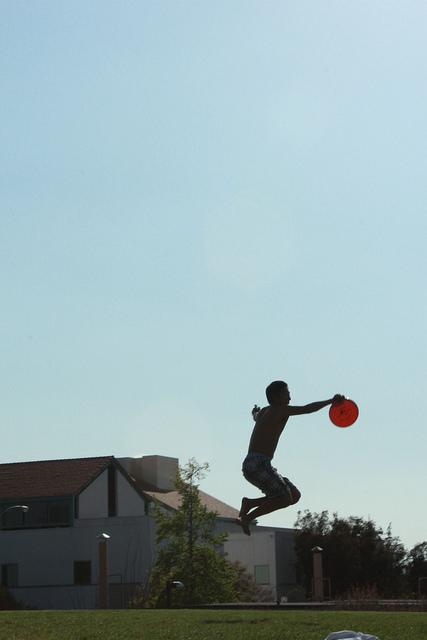What is the weather like?
Short answer required. Sunny. What time of day is it?
Keep it brief. Morning. What color is the frisbee?
Short answer required. Red. What sport is being played?
Quick response, please. Frisbee. What is the man holding?
Quick response, please. Frisbee. What is in the man's hand?
Be succinct. Frisbee. What is on this person's feet?
Quick response, please. Shoes. What is under the boy's feet?
Short answer required. Air. About how high is the man jumping?
Be succinct. 3 feet. 